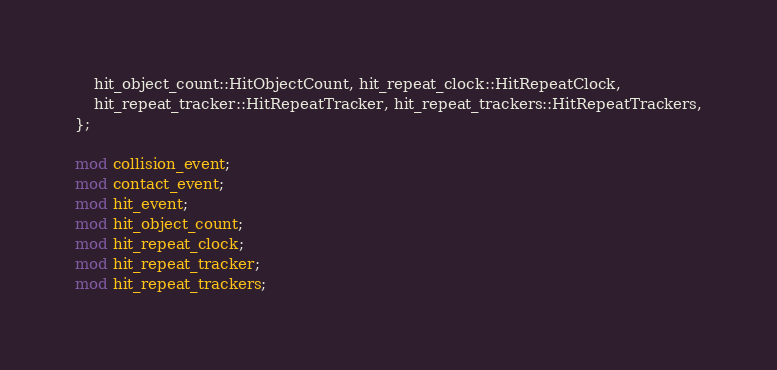<code> <loc_0><loc_0><loc_500><loc_500><_Rust_>    hit_object_count::HitObjectCount, hit_repeat_clock::HitRepeatClock,
    hit_repeat_tracker::HitRepeatTracker, hit_repeat_trackers::HitRepeatTrackers,
};

mod collision_event;
mod contact_event;
mod hit_event;
mod hit_object_count;
mod hit_repeat_clock;
mod hit_repeat_tracker;
mod hit_repeat_trackers;
</code> 